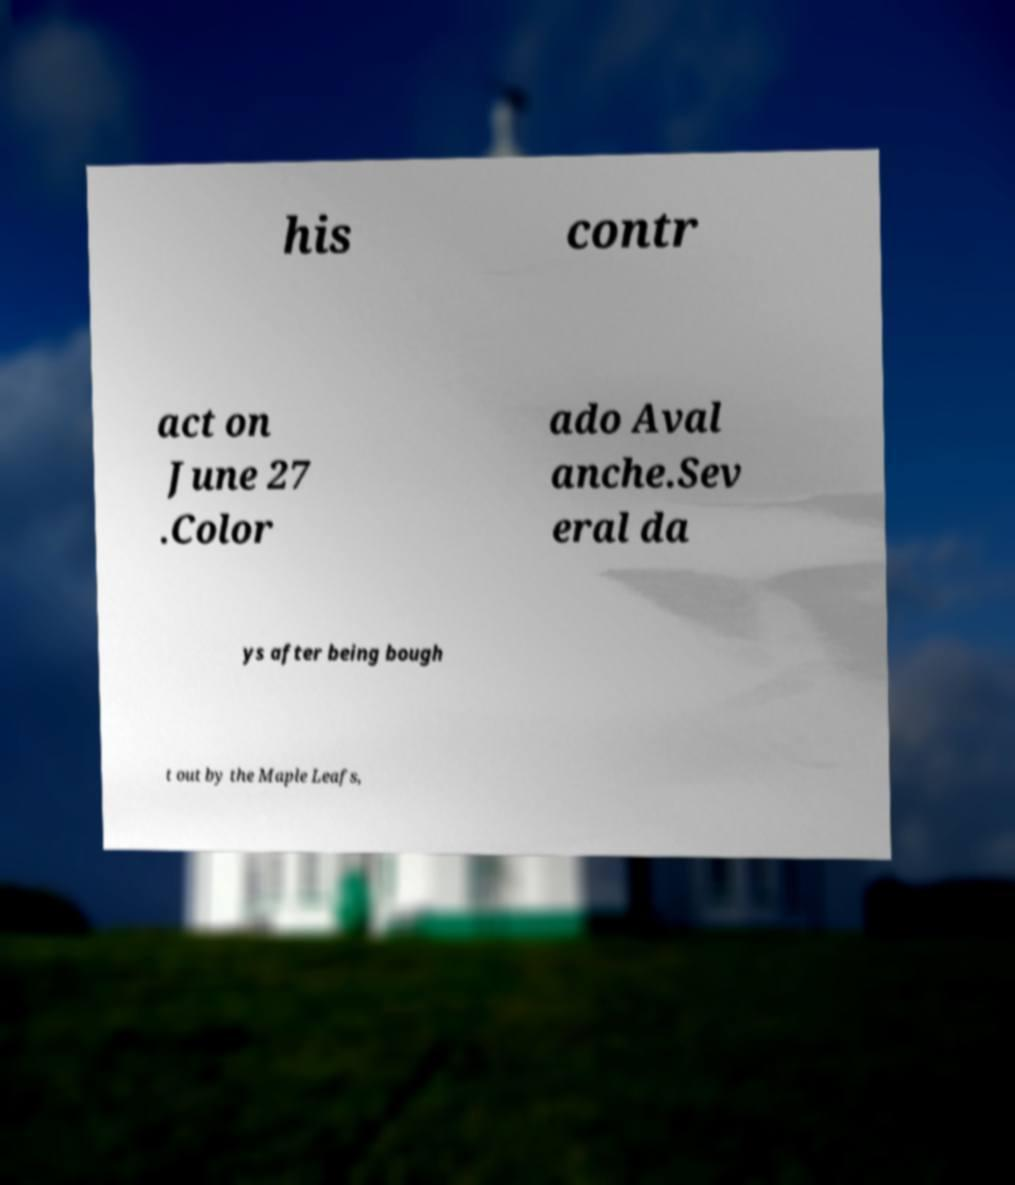Can you read and provide the text displayed in the image?This photo seems to have some interesting text. Can you extract and type it out for me? his contr act on June 27 .Color ado Aval anche.Sev eral da ys after being bough t out by the Maple Leafs, 